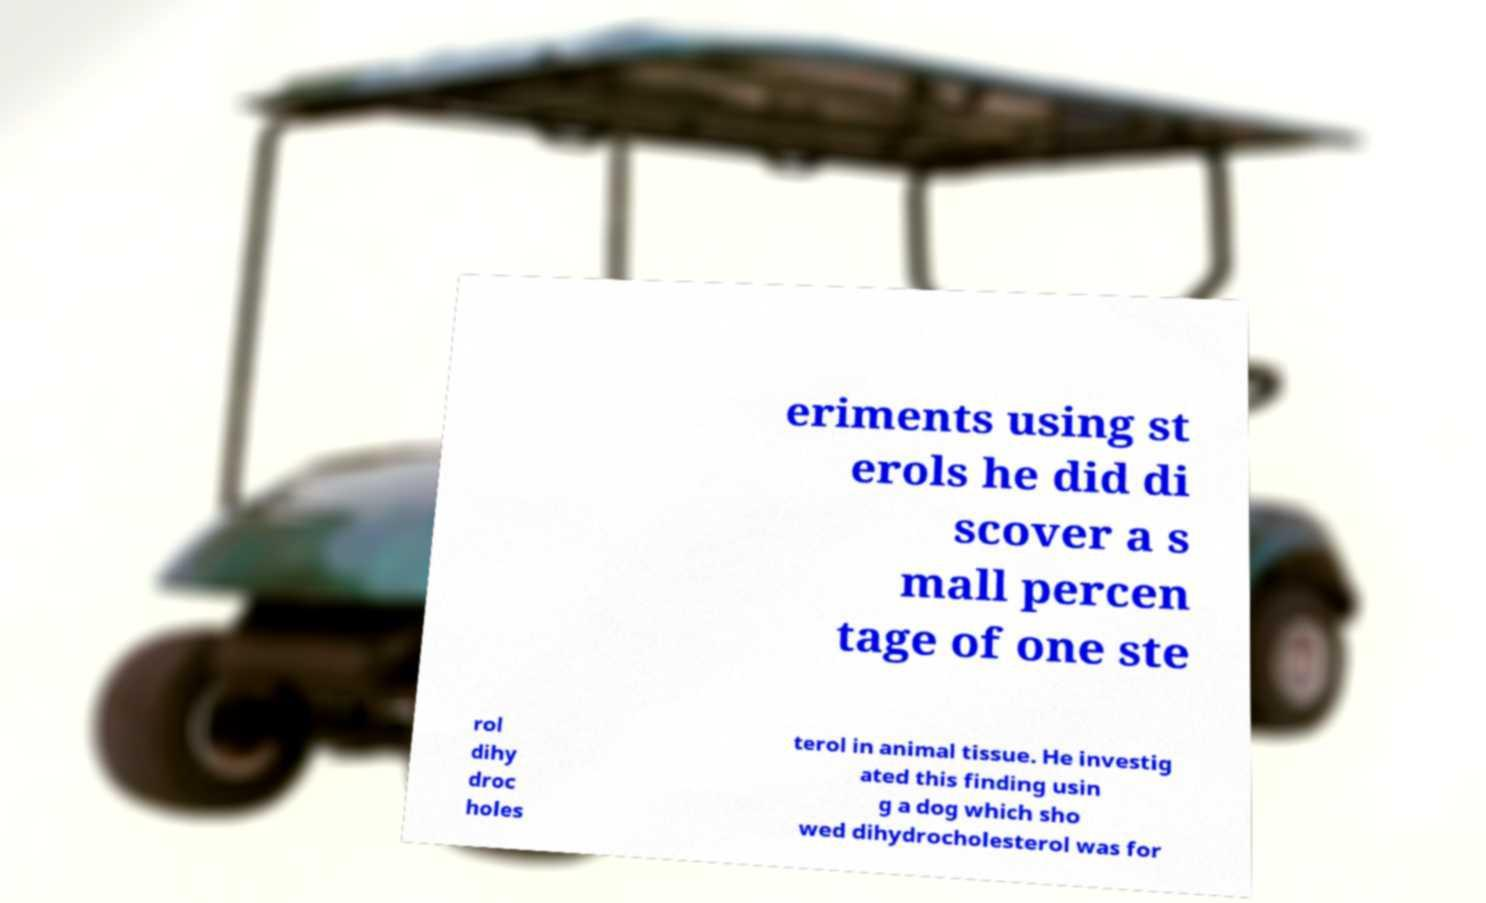For documentation purposes, I need the text within this image transcribed. Could you provide that? eriments using st erols he did di scover a s mall percen tage of one ste rol dihy droc holes terol in animal tissue. He investig ated this finding usin g a dog which sho wed dihydrocholesterol was for 